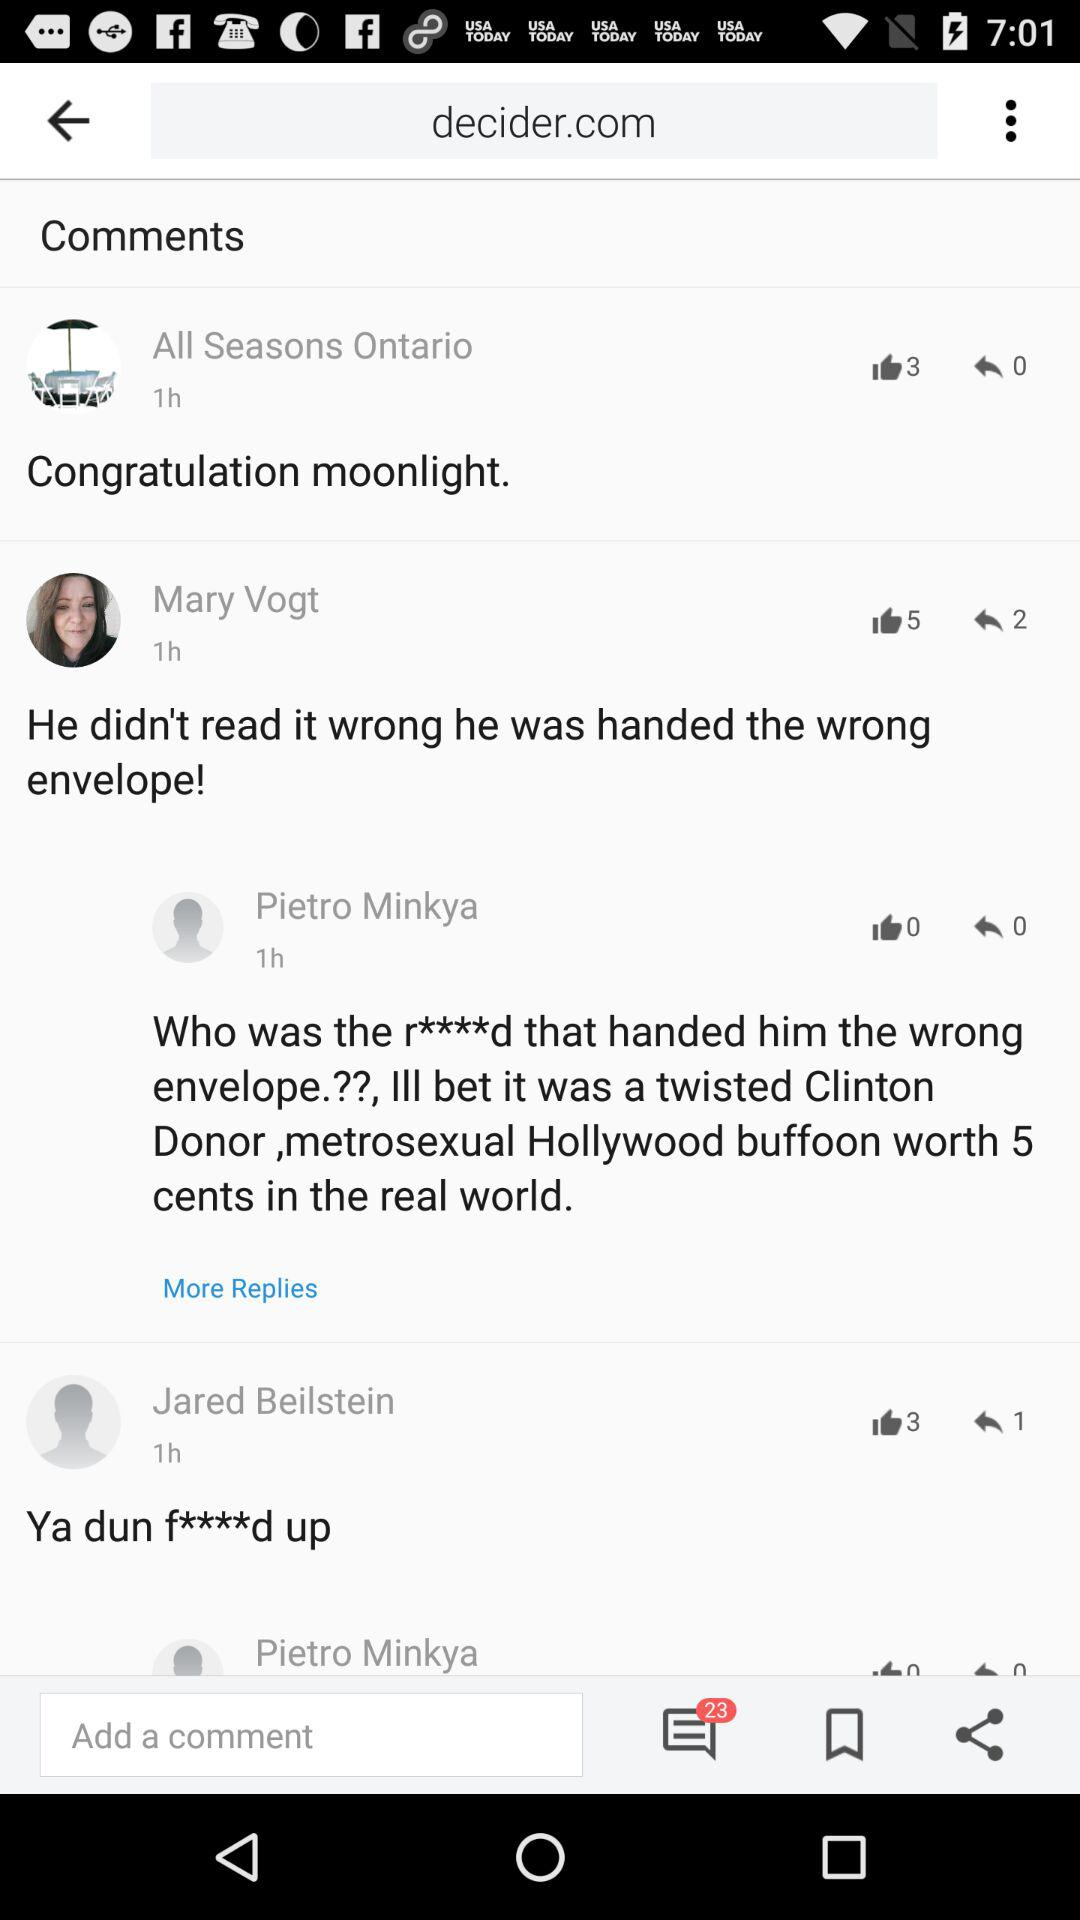How many thumbs up does the comment with the most thumbs up have?
Answer the question using a single word or phrase. 5 